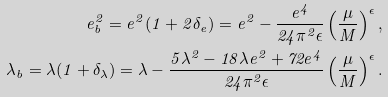<formula> <loc_0><loc_0><loc_500><loc_500>e ^ { 2 } _ { b } = e ^ { 2 } ( 1 + 2 \delta _ { e } ) = e ^ { 2 } - \frac { e ^ { 4 } } { 2 4 \pi ^ { 2 } \epsilon } \left ( \frac { \mu } { M } \right ) ^ { \epsilon } , \\ \lambda _ { b } = \lambda ( 1 + \delta _ { \lambda } ) = \lambda - \frac { 5 \lambda ^ { 2 } - 1 8 \lambda e ^ { 2 } + 7 2 e ^ { 4 } } { 2 4 \pi ^ { 2 } \epsilon } \left ( \frac { \mu } { M } \right ) ^ { \epsilon } .</formula> 